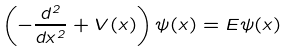<formula> <loc_0><loc_0><loc_500><loc_500>\left ( - \frac { d ^ { 2 } } { d x ^ { 2 } } + V ( x ) \right ) \psi ( x ) = E \psi ( x )</formula> 